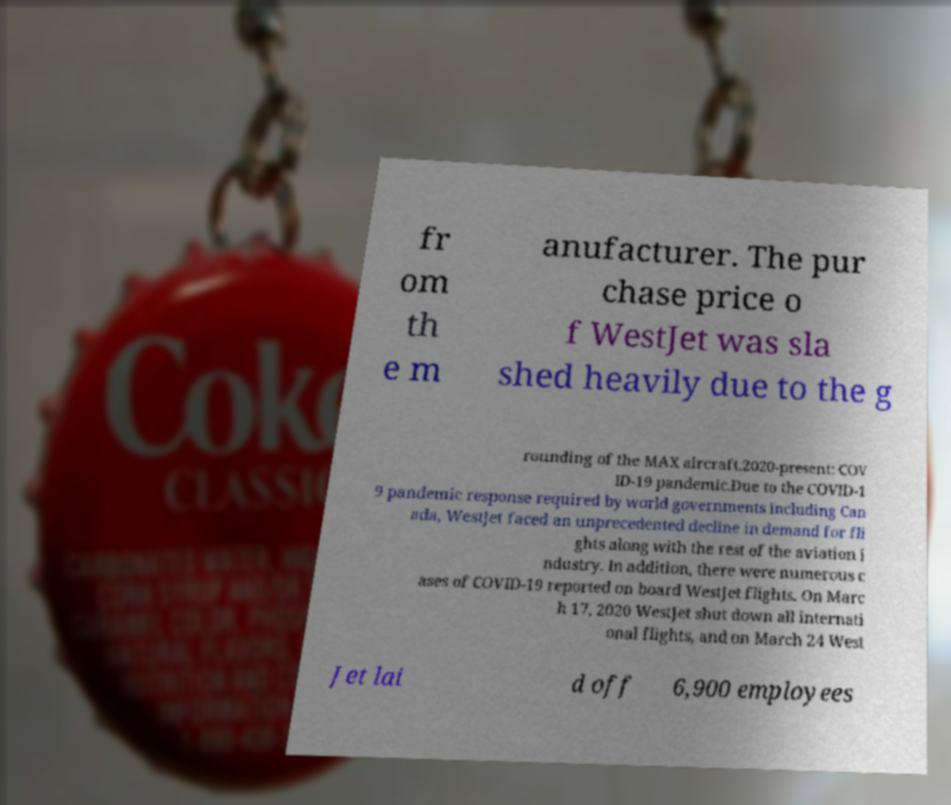There's text embedded in this image that I need extracted. Can you transcribe it verbatim? fr om th e m anufacturer. The pur chase price o f WestJet was sla shed heavily due to the g rounding of the MAX aircraft.2020-present: COV ID-19 pandemic.Due to the COVID-1 9 pandemic response required by world governments including Can ada, WestJet faced an unprecedented decline in demand for fli ghts along with the rest of the aviation i ndustry. In addition, there were numerous c ases of COVID-19 reported on board WestJet flights. On Marc h 17, 2020 WestJet shut down all internati onal flights, and on March 24 West Jet lai d off 6,900 employees 